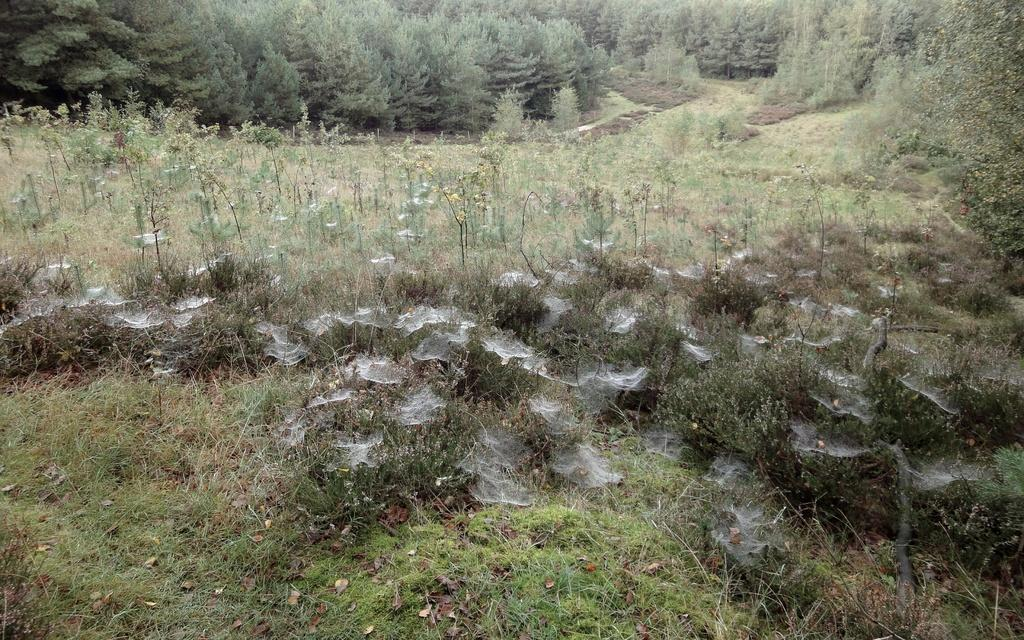What type of vegetation is present on the ground in the image? There is grass on the ground in the image. Where is the grass located in relation to the image? The grass is visible at the bottom of the image. What can be seen in the background of the image? There are trees in the background of the image. What type of arm is visible in the image? There is no arm present in the image; it features grass and trees. 